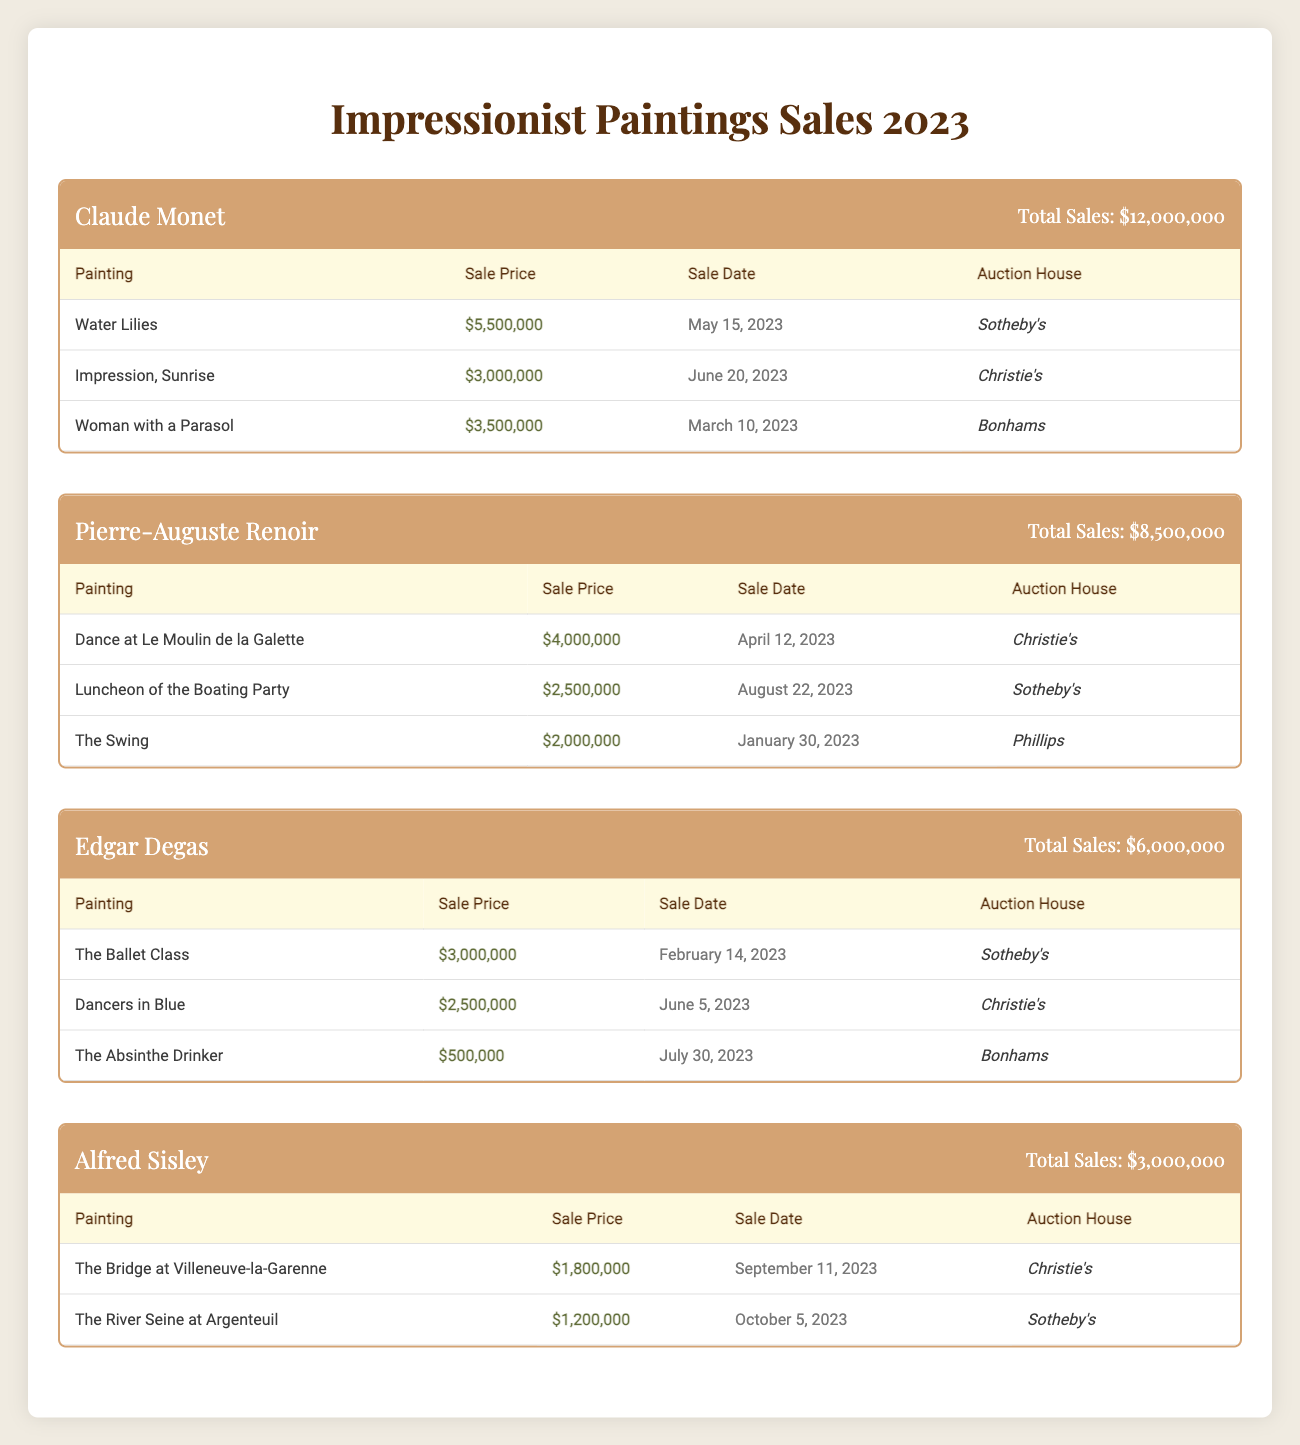What is the total sales for Claude Monet's paintings in 2023? The total sales for Claude Monet's paintings are provided directly in the table as $12,000,000.
Answer: $12,000,000 Which painting by Renoir sold for the highest price, and what was that price? The table shows that "Dance at Le Moulin de la Galette" sold for $4,000,000, which is the highest sale price among Renoir's paintings.
Answer: Dance at Le Moulin de la Galette, $4,000,000 What is the average sale price of paintings by Edgar Degas? The sale prices for Degas’s paintings are $3,000,000, $2,500,000, and $500,000. Adding them gives $6,000,000. There are 3 paintings, so average is $6,000,000/3 = $2,000,000.
Answer: $2,000,000 Is it true that Sisley had more total sales than Degas in 2023? Total sales for Sisley are $3,000,000, and for Degas, they are $6,000,000. Since $3,000,000 is less than $6,000,000, the statement is false.
Answer: No What was the sale date of Renoir's "Luncheon of the Boating Party"? The sale date for "Luncheon of the Boating Party" by Renoir is found in the table as August 22, 2023.
Answer: August 22, 2023 How many paintings did Monet sell in 2023 for over $3 million? Monet sold "Water Lilies" for $5,500,000 and "Woman with a Parasol" for $3,500,000. These are two paintings sold for over $3 million.
Answer: 2 What is the total sales of all Impressionist paintings combined for 2023? The total sales can be calculated by adding Monet's ($12,000,000), Renoir's ($8,500,000), Degas' ($6,000,000), and Sisley's ($3,000,000). The sum is $12,000,000 + $8,500,000 + $6,000,000 + $3,000,000 = $29,500,000.
Answer: $29,500,000 Which auction house had the highest number of paintings sold by Monet? Monet had three paintings sold at different auction houses: Sotheby's, Christie's, and Bonhams. Each auction house sold one painting, so there is no auction house with more than one sale.
Answer: None (equal distribution) Was any painting by Sisley sold at Sotheby’s in 2023? The table shows that "The River Seine at Argenteuil," one of Sisley's paintings, was sold at Sotheby's. Therefore, the answer is yes.
Answer: Yes 